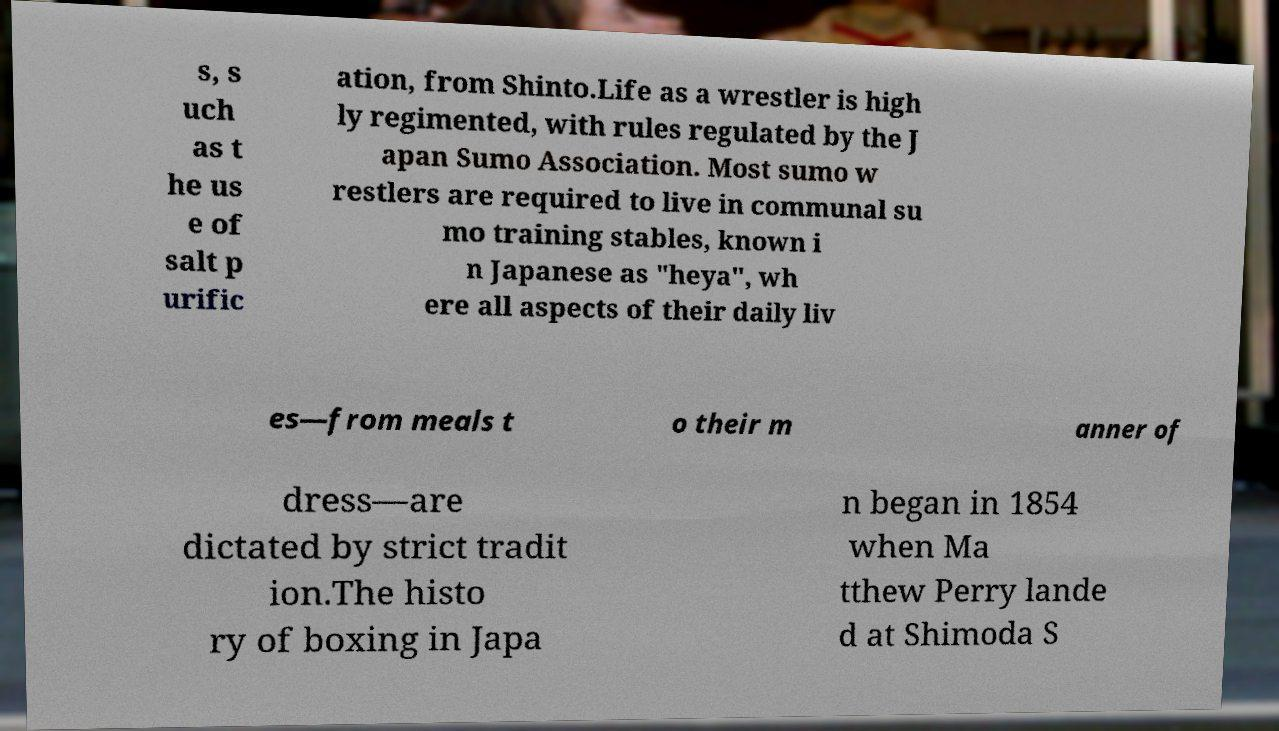There's text embedded in this image that I need extracted. Can you transcribe it verbatim? s, s uch as t he us e of salt p urific ation, from Shinto.Life as a wrestler is high ly regimented, with rules regulated by the J apan Sumo Association. Most sumo w restlers are required to live in communal su mo training stables, known i n Japanese as "heya", wh ere all aspects of their daily liv es—from meals t o their m anner of dress—are dictated by strict tradit ion.The histo ry of boxing in Japa n began in 1854 when Ma tthew Perry lande d at Shimoda S 